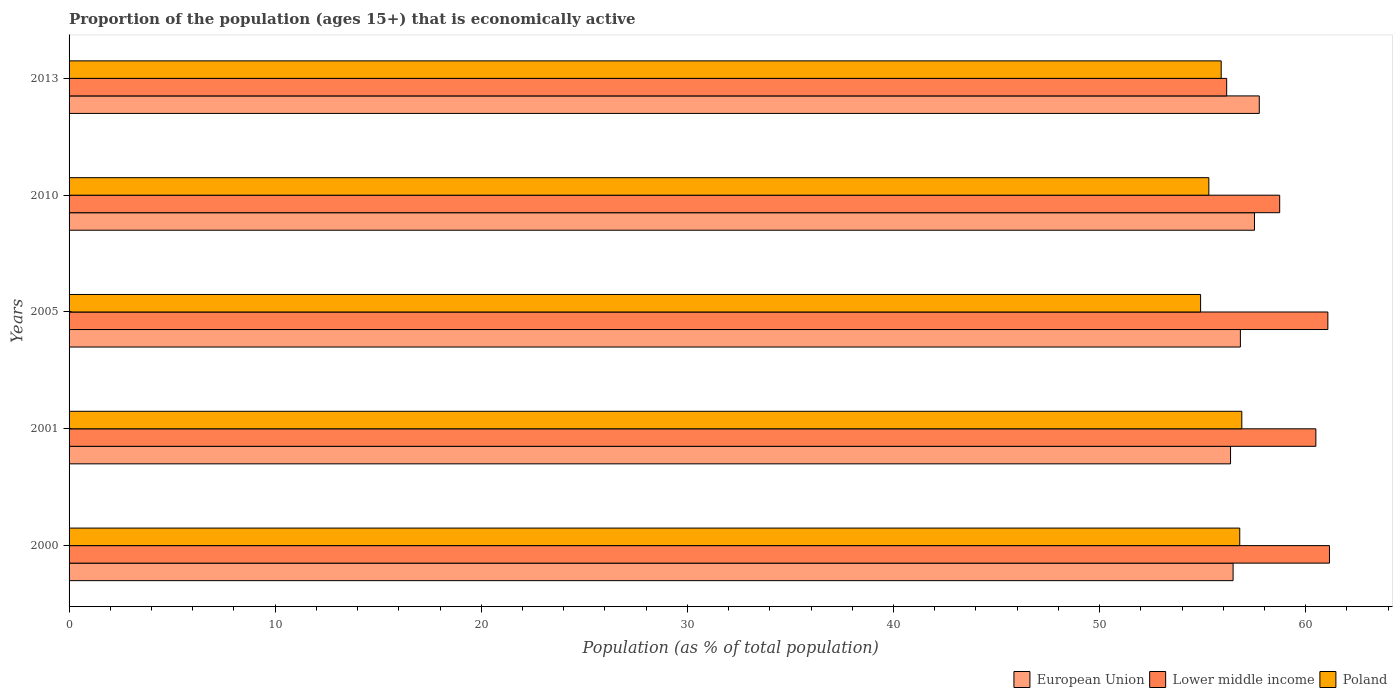How many different coloured bars are there?
Provide a short and direct response. 3. In how many cases, is the number of bars for a given year not equal to the number of legend labels?
Keep it short and to the point. 0. What is the proportion of the population that is economically active in European Union in 2000?
Your response must be concise. 56.48. Across all years, what is the maximum proportion of the population that is economically active in Lower middle income?
Give a very brief answer. 61.15. Across all years, what is the minimum proportion of the population that is economically active in Lower middle income?
Give a very brief answer. 56.17. In which year was the proportion of the population that is economically active in Lower middle income maximum?
Keep it short and to the point. 2000. What is the total proportion of the population that is economically active in Poland in the graph?
Give a very brief answer. 279.8. What is the difference between the proportion of the population that is economically active in Poland in 2001 and that in 2013?
Provide a short and direct response. 1. What is the difference between the proportion of the population that is economically active in Poland in 2010 and the proportion of the population that is economically active in European Union in 2005?
Ensure brevity in your answer.  -1.53. What is the average proportion of the population that is economically active in Poland per year?
Your answer should be compact. 55.96. In the year 2013, what is the difference between the proportion of the population that is economically active in European Union and proportion of the population that is economically active in Lower middle income?
Offer a very short reply. 1.58. What is the ratio of the proportion of the population that is economically active in European Union in 2005 to that in 2010?
Provide a succinct answer. 0.99. Is the proportion of the population that is economically active in European Union in 2000 less than that in 2005?
Keep it short and to the point. Yes. What is the difference between the highest and the second highest proportion of the population that is economically active in Poland?
Keep it short and to the point. 0.1. Is the sum of the proportion of the population that is economically active in Lower middle income in 2001 and 2013 greater than the maximum proportion of the population that is economically active in European Union across all years?
Make the answer very short. Yes. Is it the case that in every year, the sum of the proportion of the population that is economically active in Poland and proportion of the population that is economically active in European Union is greater than the proportion of the population that is economically active in Lower middle income?
Provide a short and direct response. Yes. Are all the bars in the graph horizontal?
Ensure brevity in your answer.  Yes. How many years are there in the graph?
Make the answer very short. 5. What is the difference between two consecutive major ticks on the X-axis?
Your answer should be compact. 10. Does the graph contain grids?
Your response must be concise. No. Where does the legend appear in the graph?
Ensure brevity in your answer.  Bottom right. What is the title of the graph?
Make the answer very short. Proportion of the population (ages 15+) that is economically active. What is the label or title of the X-axis?
Provide a succinct answer. Population (as % of total population). What is the label or title of the Y-axis?
Offer a very short reply. Years. What is the Population (as % of total population) in European Union in 2000?
Your answer should be very brief. 56.48. What is the Population (as % of total population) in Lower middle income in 2000?
Ensure brevity in your answer.  61.15. What is the Population (as % of total population) in Poland in 2000?
Make the answer very short. 56.8. What is the Population (as % of total population) in European Union in 2001?
Provide a succinct answer. 56.35. What is the Population (as % of total population) of Lower middle income in 2001?
Provide a succinct answer. 60.49. What is the Population (as % of total population) in Poland in 2001?
Offer a very short reply. 56.9. What is the Population (as % of total population) of European Union in 2005?
Your answer should be compact. 56.83. What is the Population (as % of total population) of Lower middle income in 2005?
Provide a succinct answer. 61.07. What is the Population (as % of total population) of Poland in 2005?
Your answer should be compact. 54.9. What is the Population (as % of total population) of European Union in 2010?
Provide a succinct answer. 57.51. What is the Population (as % of total population) in Lower middle income in 2010?
Keep it short and to the point. 58.74. What is the Population (as % of total population) of Poland in 2010?
Provide a succinct answer. 55.3. What is the Population (as % of total population) of European Union in 2013?
Keep it short and to the point. 57.75. What is the Population (as % of total population) in Lower middle income in 2013?
Offer a very short reply. 56.17. What is the Population (as % of total population) of Poland in 2013?
Your answer should be very brief. 55.9. Across all years, what is the maximum Population (as % of total population) in European Union?
Ensure brevity in your answer.  57.75. Across all years, what is the maximum Population (as % of total population) of Lower middle income?
Give a very brief answer. 61.15. Across all years, what is the maximum Population (as % of total population) of Poland?
Provide a succinct answer. 56.9. Across all years, what is the minimum Population (as % of total population) of European Union?
Your answer should be very brief. 56.35. Across all years, what is the minimum Population (as % of total population) in Lower middle income?
Make the answer very short. 56.17. Across all years, what is the minimum Population (as % of total population) of Poland?
Your answer should be very brief. 54.9. What is the total Population (as % of total population) of European Union in the graph?
Your answer should be compact. 284.92. What is the total Population (as % of total population) in Lower middle income in the graph?
Offer a terse response. 297.62. What is the total Population (as % of total population) in Poland in the graph?
Make the answer very short. 279.8. What is the difference between the Population (as % of total population) of European Union in 2000 and that in 2001?
Give a very brief answer. 0.12. What is the difference between the Population (as % of total population) in Lower middle income in 2000 and that in 2001?
Your response must be concise. 0.66. What is the difference between the Population (as % of total population) in Poland in 2000 and that in 2001?
Give a very brief answer. -0.1. What is the difference between the Population (as % of total population) of European Union in 2000 and that in 2005?
Ensure brevity in your answer.  -0.35. What is the difference between the Population (as % of total population) of Lower middle income in 2000 and that in 2005?
Provide a succinct answer. 0.08. What is the difference between the Population (as % of total population) in Poland in 2000 and that in 2005?
Offer a terse response. 1.9. What is the difference between the Population (as % of total population) of European Union in 2000 and that in 2010?
Make the answer very short. -1.04. What is the difference between the Population (as % of total population) of Lower middle income in 2000 and that in 2010?
Offer a very short reply. 2.42. What is the difference between the Population (as % of total population) in Poland in 2000 and that in 2010?
Your answer should be compact. 1.5. What is the difference between the Population (as % of total population) of European Union in 2000 and that in 2013?
Offer a very short reply. -1.27. What is the difference between the Population (as % of total population) of Lower middle income in 2000 and that in 2013?
Your answer should be very brief. 4.99. What is the difference between the Population (as % of total population) of Poland in 2000 and that in 2013?
Offer a very short reply. 0.9. What is the difference between the Population (as % of total population) in European Union in 2001 and that in 2005?
Your response must be concise. -0.48. What is the difference between the Population (as % of total population) in Lower middle income in 2001 and that in 2005?
Your answer should be very brief. -0.58. What is the difference between the Population (as % of total population) of European Union in 2001 and that in 2010?
Make the answer very short. -1.16. What is the difference between the Population (as % of total population) in Lower middle income in 2001 and that in 2010?
Your response must be concise. 1.75. What is the difference between the Population (as % of total population) of European Union in 2001 and that in 2013?
Keep it short and to the point. -1.39. What is the difference between the Population (as % of total population) in Lower middle income in 2001 and that in 2013?
Your response must be concise. 4.33. What is the difference between the Population (as % of total population) in Poland in 2001 and that in 2013?
Your answer should be compact. 1. What is the difference between the Population (as % of total population) of European Union in 2005 and that in 2010?
Your answer should be compact. -0.68. What is the difference between the Population (as % of total population) of Lower middle income in 2005 and that in 2010?
Ensure brevity in your answer.  2.34. What is the difference between the Population (as % of total population) of European Union in 2005 and that in 2013?
Provide a succinct answer. -0.92. What is the difference between the Population (as % of total population) in Lower middle income in 2005 and that in 2013?
Your answer should be compact. 4.91. What is the difference between the Population (as % of total population) in Poland in 2005 and that in 2013?
Your answer should be very brief. -1. What is the difference between the Population (as % of total population) of European Union in 2010 and that in 2013?
Ensure brevity in your answer.  -0.23. What is the difference between the Population (as % of total population) in Lower middle income in 2010 and that in 2013?
Offer a terse response. 2.57. What is the difference between the Population (as % of total population) in European Union in 2000 and the Population (as % of total population) in Lower middle income in 2001?
Make the answer very short. -4.02. What is the difference between the Population (as % of total population) in European Union in 2000 and the Population (as % of total population) in Poland in 2001?
Give a very brief answer. -0.42. What is the difference between the Population (as % of total population) of Lower middle income in 2000 and the Population (as % of total population) of Poland in 2001?
Your response must be concise. 4.25. What is the difference between the Population (as % of total population) in European Union in 2000 and the Population (as % of total population) in Lower middle income in 2005?
Give a very brief answer. -4.6. What is the difference between the Population (as % of total population) in European Union in 2000 and the Population (as % of total population) in Poland in 2005?
Provide a short and direct response. 1.58. What is the difference between the Population (as % of total population) of Lower middle income in 2000 and the Population (as % of total population) of Poland in 2005?
Offer a very short reply. 6.25. What is the difference between the Population (as % of total population) of European Union in 2000 and the Population (as % of total population) of Lower middle income in 2010?
Give a very brief answer. -2.26. What is the difference between the Population (as % of total population) of European Union in 2000 and the Population (as % of total population) of Poland in 2010?
Your answer should be compact. 1.18. What is the difference between the Population (as % of total population) in Lower middle income in 2000 and the Population (as % of total population) in Poland in 2010?
Offer a terse response. 5.85. What is the difference between the Population (as % of total population) of European Union in 2000 and the Population (as % of total population) of Lower middle income in 2013?
Make the answer very short. 0.31. What is the difference between the Population (as % of total population) of European Union in 2000 and the Population (as % of total population) of Poland in 2013?
Your response must be concise. 0.58. What is the difference between the Population (as % of total population) of Lower middle income in 2000 and the Population (as % of total population) of Poland in 2013?
Your response must be concise. 5.25. What is the difference between the Population (as % of total population) in European Union in 2001 and the Population (as % of total population) in Lower middle income in 2005?
Offer a terse response. -4.72. What is the difference between the Population (as % of total population) of European Union in 2001 and the Population (as % of total population) of Poland in 2005?
Provide a short and direct response. 1.45. What is the difference between the Population (as % of total population) of Lower middle income in 2001 and the Population (as % of total population) of Poland in 2005?
Offer a terse response. 5.59. What is the difference between the Population (as % of total population) of European Union in 2001 and the Population (as % of total population) of Lower middle income in 2010?
Provide a short and direct response. -2.38. What is the difference between the Population (as % of total population) in European Union in 2001 and the Population (as % of total population) in Poland in 2010?
Your answer should be very brief. 1.05. What is the difference between the Population (as % of total population) of Lower middle income in 2001 and the Population (as % of total population) of Poland in 2010?
Make the answer very short. 5.19. What is the difference between the Population (as % of total population) of European Union in 2001 and the Population (as % of total population) of Lower middle income in 2013?
Make the answer very short. 0.19. What is the difference between the Population (as % of total population) of European Union in 2001 and the Population (as % of total population) of Poland in 2013?
Make the answer very short. 0.45. What is the difference between the Population (as % of total population) of Lower middle income in 2001 and the Population (as % of total population) of Poland in 2013?
Give a very brief answer. 4.59. What is the difference between the Population (as % of total population) of European Union in 2005 and the Population (as % of total population) of Lower middle income in 2010?
Provide a succinct answer. -1.91. What is the difference between the Population (as % of total population) of European Union in 2005 and the Population (as % of total population) of Poland in 2010?
Your answer should be compact. 1.53. What is the difference between the Population (as % of total population) of Lower middle income in 2005 and the Population (as % of total population) of Poland in 2010?
Make the answer very short. 5.77. What is the difference between the Population (as % of total population) in European Union in 2005 and the Population (as % of total population) in Lower middle income in 2013?
Offer a terse response. 0.66. What is the difference between the Population (as % of total population) in European Union in 2005 and the Population (as % of total population) in Poland in 2013?
Offer a terse response. 0.93. What is the difference between the Population (as % of total population) of Lower middle income in 2005 and the Population (as % of total population) of Poland in 2013?
Provide a succinct answer. 5.17. What is the difference between the Population (as % of total population) in European Union in 2010 and the Population (as % of total population) in Lower middle income in 2013?
Your answer should be very brief. 1.35. What is the difference between the Population (as % of total population) of European Union in 2010 and the Population (as % of total population) of Poland in 2013?
Provide a succinct answer. 1.61. What is the difference between the Population (as % of total population) of Lower middle income in 2010 and the Population (as % of total population) of Poland in 2013?
Make the answer very short. 2.84. What is the average Population (as % of total population) of European Union per year?
Provide a succinct answer. 56.98. What is the average Population (as % of total population) in Lower middle income per year?
Your answer should be compact. 59.52. What is the average Population (as % of total population) in Poland per year?
Provide a succinct answer. 55.96. In the year 2000, what is the difference between the Population (as % of total population) of European Union and Population (as % of total population) of Lower middle income?
Give a very brief answer. -4.68. In the year 2000, what is the difference between the Population (as % of total population) in European Union and Population (as % of total population) in Poland?
Keep it short and to the point. -0.32. In the year 2000, what is the difference between the Population (as % of total population) of Lower middle income and Population (as % of total population) of Poland?
Offer a very short reply. 4.35. In the year 2001, what is the difference between the Population (as % of total population) of European Union and Population (as % of total population) of Lower middle income?
Offer a very short reply. -4.14. In the year 2001, what is the difference between the Population (as % of total population) in European Union and Population (as % of total population) in Poland?
Your answer should be very brief. -0.55. In the year 2001, what is the difference between the Population (as % of total population) of Lower middle income and Population (as % of total population) of Poland?
Ensure brevity in your answer.  3.59. In the year 2005, what is the difference between the Population (as % of total population) in European Union and Population (as % of total population) in Lower middle income?
Provide a succinct answer. -4.24. In the year 2005, what is the difference between the Population (as % of total population) of European Union and Population (as % of total population) of Poland?
Provide a short and direct response. 1.93. In the year 2005, what is the difference between the Population (as % of total population) in Lower middle income and Population (as % of total population) in Poland?
Provide a succinct answer. 6.17. In the year 2010, what is the difference between the Population (as % of total population) in European Union and Population (as % of total population) in Lower middle income?
Your answer should be very brief. -1.22. In the year 2010, what is the difference between the Population (as % of total population) in European Union and Population (as % of total population) in Poland?
Give a very brief answer. 2.21. In the year 2010, what is the difference between the Population (as % of total population) in Lower middle income and Population (as % of total population) in Poland?
Provide a succinct answer. 3.44. In the year 2013, what is the difference between the Population (as % of total population) of European Union and Population (as % of total population) of Lower middle income?
Give a very brief answer. 1.58. In the year 2013, what is the difference between the Population (as % of total population) in European Union and Population (as % of total population) in Poland?
Ensure brevity in your answer.  1.85. In the year 2013, what is the difference between the Population (as % of total population) of Lower middle income and Population (as % of total population) of Poland?
Ensure brevity in your answer.  0.27. What is the ratio of the Population (as % of total population) in Lower middle income in 2000 to that in 2001?
Offer a terse response. 1.01. What is the ratio of the Population (as % of total population) of Poland in 2000 to that in 2005?
Provide a short and direct response. 1.03. What is the ratio of the Population (as % of total population) in Lower middle income in 2000 to that in 2010?
Offer a terse response. 1.04. What is the ratio of the Population (as % of total population) of Poland in 2000 to that in 2010?
Offer a very short reply. 1.03. What is the ratio of the Population (as % of total population) of European Union in 2000 to that in 2013?
Give a very brief answer. 0.98. What is the ratio of the Population (as % of total population) in Lower middle income in 2000 to that in 2013?
Give a very brief answer. 1.09. What is the ratio of the Population (as % of total population) of Poland in 2000 to that in 2013?
Your answer should be very brief. 1.02. What is the ratio of the Population (as % of total population) in European Union in 2001 to that in 2005?
Your answer should be very brief. 0.99. What is the ratio of the Population (as % of total population) in Poland in 2001 to that in 2005?
Offer a very short reply. 1.04. What is the ratio of the Population (as % of total population) of European Union in 2001 to that in 2010?
Provide a short and direct response. 0.98. What is the ratio of the Population (as % of total population) of Lower middle income in 2001 to that in 2010?
Provide a short and direct response. 1.03. What is the ratio of the Population (as % of total population) of Poland in 2001 to that in 2010?
Provide a short and direct response. 1.03. What is the ratio of the Population (as % of total population) of European Union in 2001 to that in 2013?
Give a very brief answer. 0.98. What is the ratio of the Population (as % of total population) of Lower middle income in 2001 to that in 2013?
Your answer should be compact. 1.08. What is the ratio of the Population (as % of total population) of Poland in 2001 to that in 2013?
Your answer should be very brief. 1.02. What is the ratio of the Population (as % of total population) of Lower middle income in 2005 to that in 2010?
Provide a succinct answer. 1.04. What is the ratio of the Population (as % of total population) in European Union in 2005 to that in 2013?
Offer a very short reply. 0.98. What is the ratio of the Population (as % of total population) in Lower middle income in 2005 to that in 2013?
Your answer should be very brief. 1.09. What is the ratio of the Population (as % of total population) in Poland in 2005 to that in 2013?
Keep it short and to the point. 0.98. What is the ratio of the Population (as % of total population) of Lower middle income in 2010 to that in 2013?
Your answer should be compact. 1.05. What is the ratio of the Population (as % of total population) in Poland in 2010 to that in 2013?
Your answer should be compact. 0.99. What is the difference between the highest and the second highest Population (as % of total population) in European Union?
Your answer should be very brief. 0.23. What is the difference between the highest and the second highest Population (as % of total population) of Lower middle income?
Your answer should be very brief. 0.08. What is the difference between the highest and the lowest Population (as % of total population) of European Union?
Provide a succinct answer. 1.39. What is the difference between the highest and the lowest Population (as % of total population) of Lower middle income?
Your answer should be compact. 4.99. 